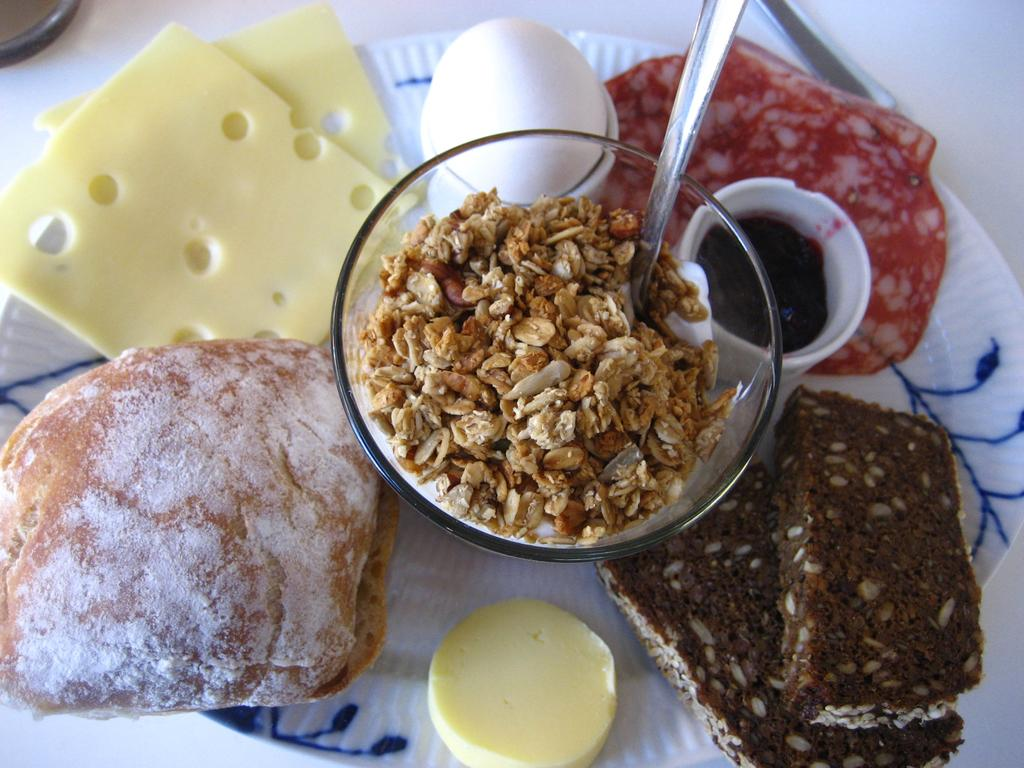What is placed on a surface in the image? There is a plate on a surface in the image. What is on the plate? There is a spoon on the plate, as well as bowls and food items. Can you describe the food items on the plate? Unfortunately, the specific food items cannot be determined from the provided facts. How does the nail grow in the image? A: There is no nail present in the image, so it is not possible to determine how it might grow. 